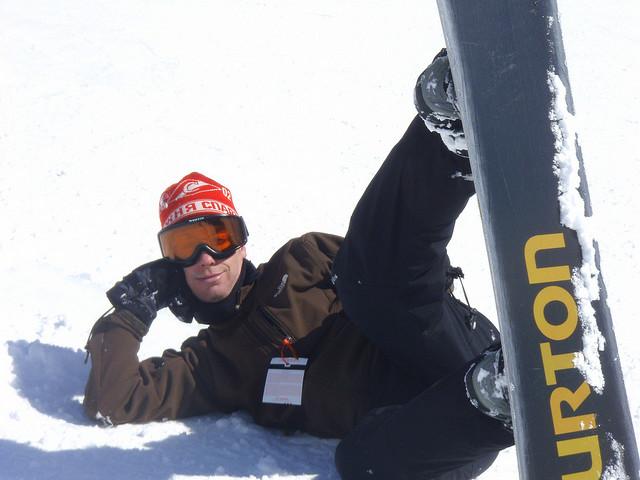What color are the men's ski goggles?
Concise answer only. Black. What color is the man's cap?
Write a very short answer. Red. What color is the snow?
Give a very brief answer. White. 